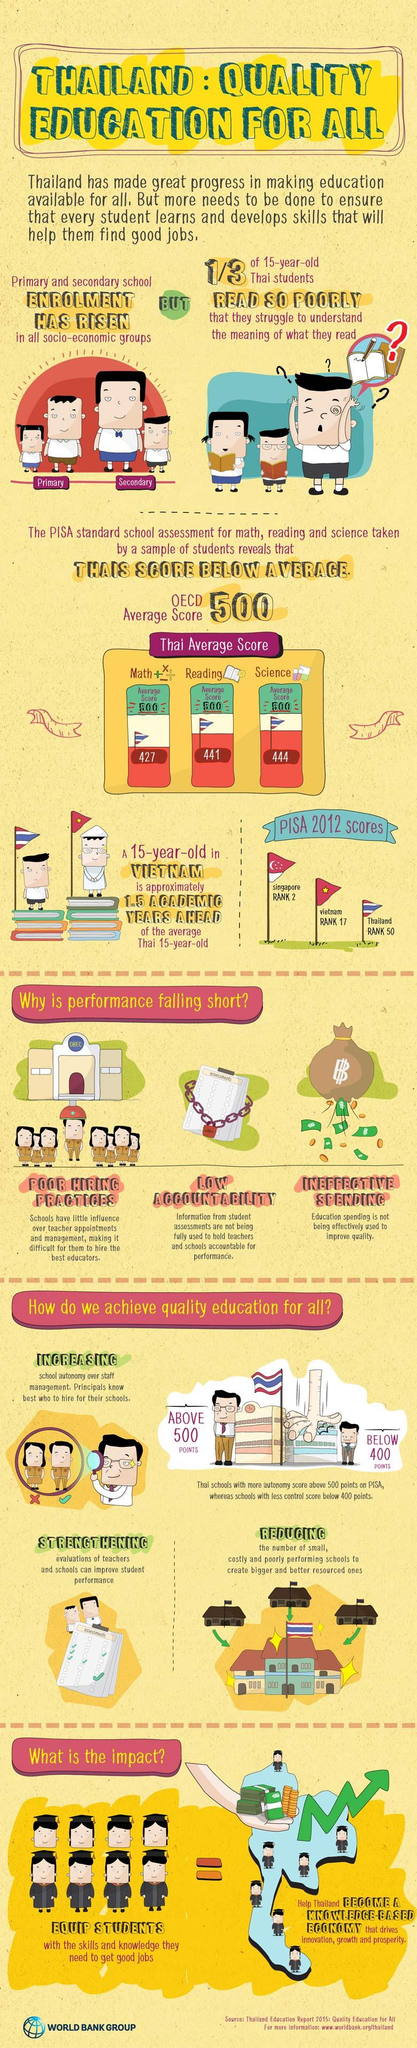Point out several critical features in this image. The Thai average score for maths according to the PISA standard school assessment is 427 out of 500. According to the PISA standard school assessment, the Thai average score for science is 444 out of 500. The Thai average score for reading according to the PISA standard school assessment is 441 out of 500. Thailand's quality education is declining due to poor hiring practices and a lack of accountability, as well as ineffective spending. 